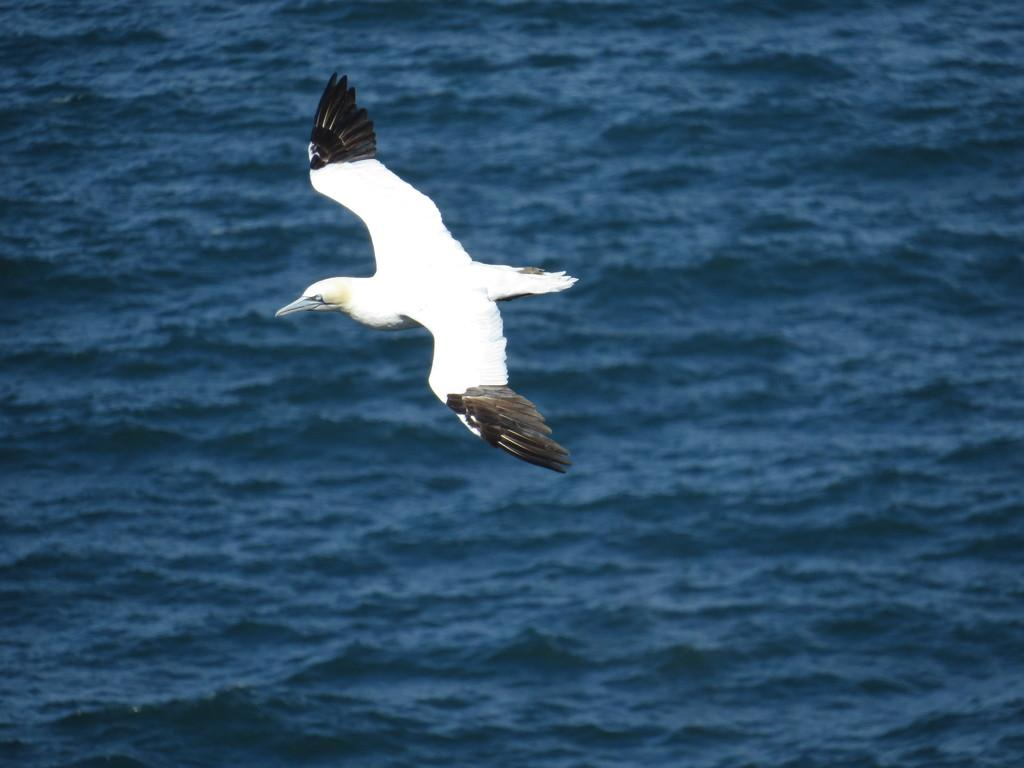What is flying in the air in the image? There is a bird in the air in the image. What type of environment can be seen in the image? There is a sea visible in the image. What type of noise can be heard coming from the bird in the image? There is no information about the bird's noise in the image, so it cannot be determined. 